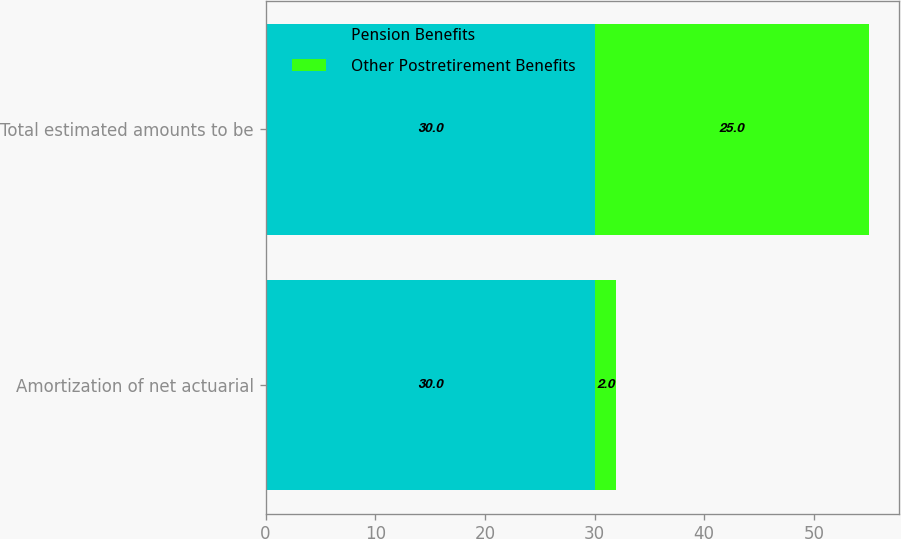Convert chart to OTSL. <chart><loc_0><loc_0><loc_500><loc_500><stacked_bar_chart><ecel><fcel>Amortization of net actuarial<fcel>Total estimated amounts to be<nl><fcel>Pension Benefits<fcel>30<fcel>30<nl><fcel>Other Postretirement Benefits<fcel>2<fcel>25<nl></chart> 